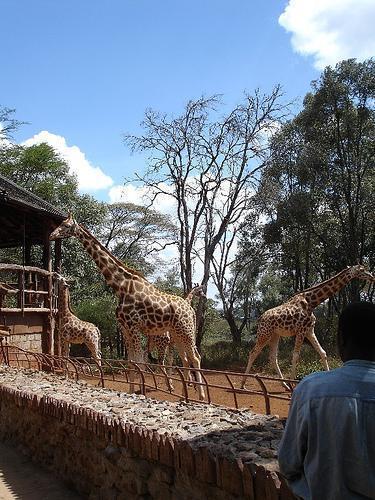What prevents the Giraffes from escaping the fence?
Select the accurate answer and provide justification: `Answer: choice
Rationale: srationale.`
Options: Material, color, it's width, texture. Answer: it's width.
Rationale: The giraffes are too tall to escape. 